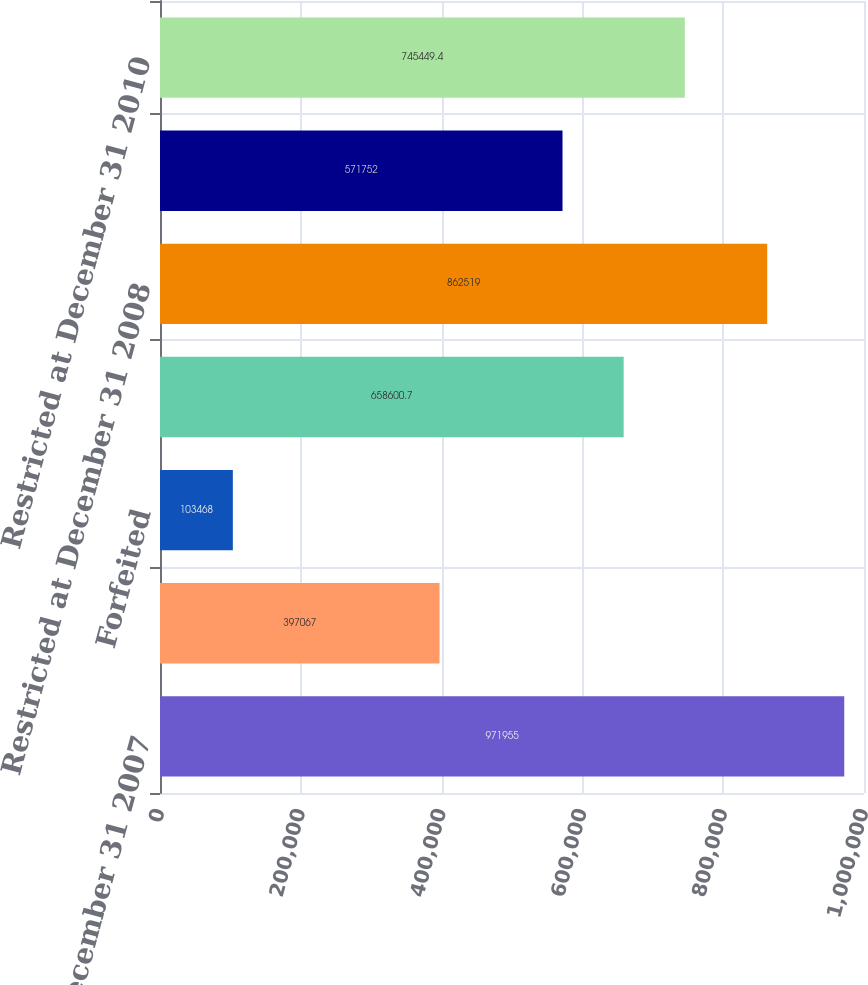Convert chart. <chart><loc_0><loc_0><loc_500><loc_500><bar_chart><fcel>Restricted at December 31 2007<fcel>Granted<fcel>Forfeited<fcel>Released<fcel>Restricted at December 31 2008<fcel>Restricted at December 31 2009<fcel>Restricted at December 31 2010<nl><fcel>971955<fcel>397067<fcel>103468<fcel>658601<fcel>862519<fcel>571752<fcel>745449<nl></chart> 